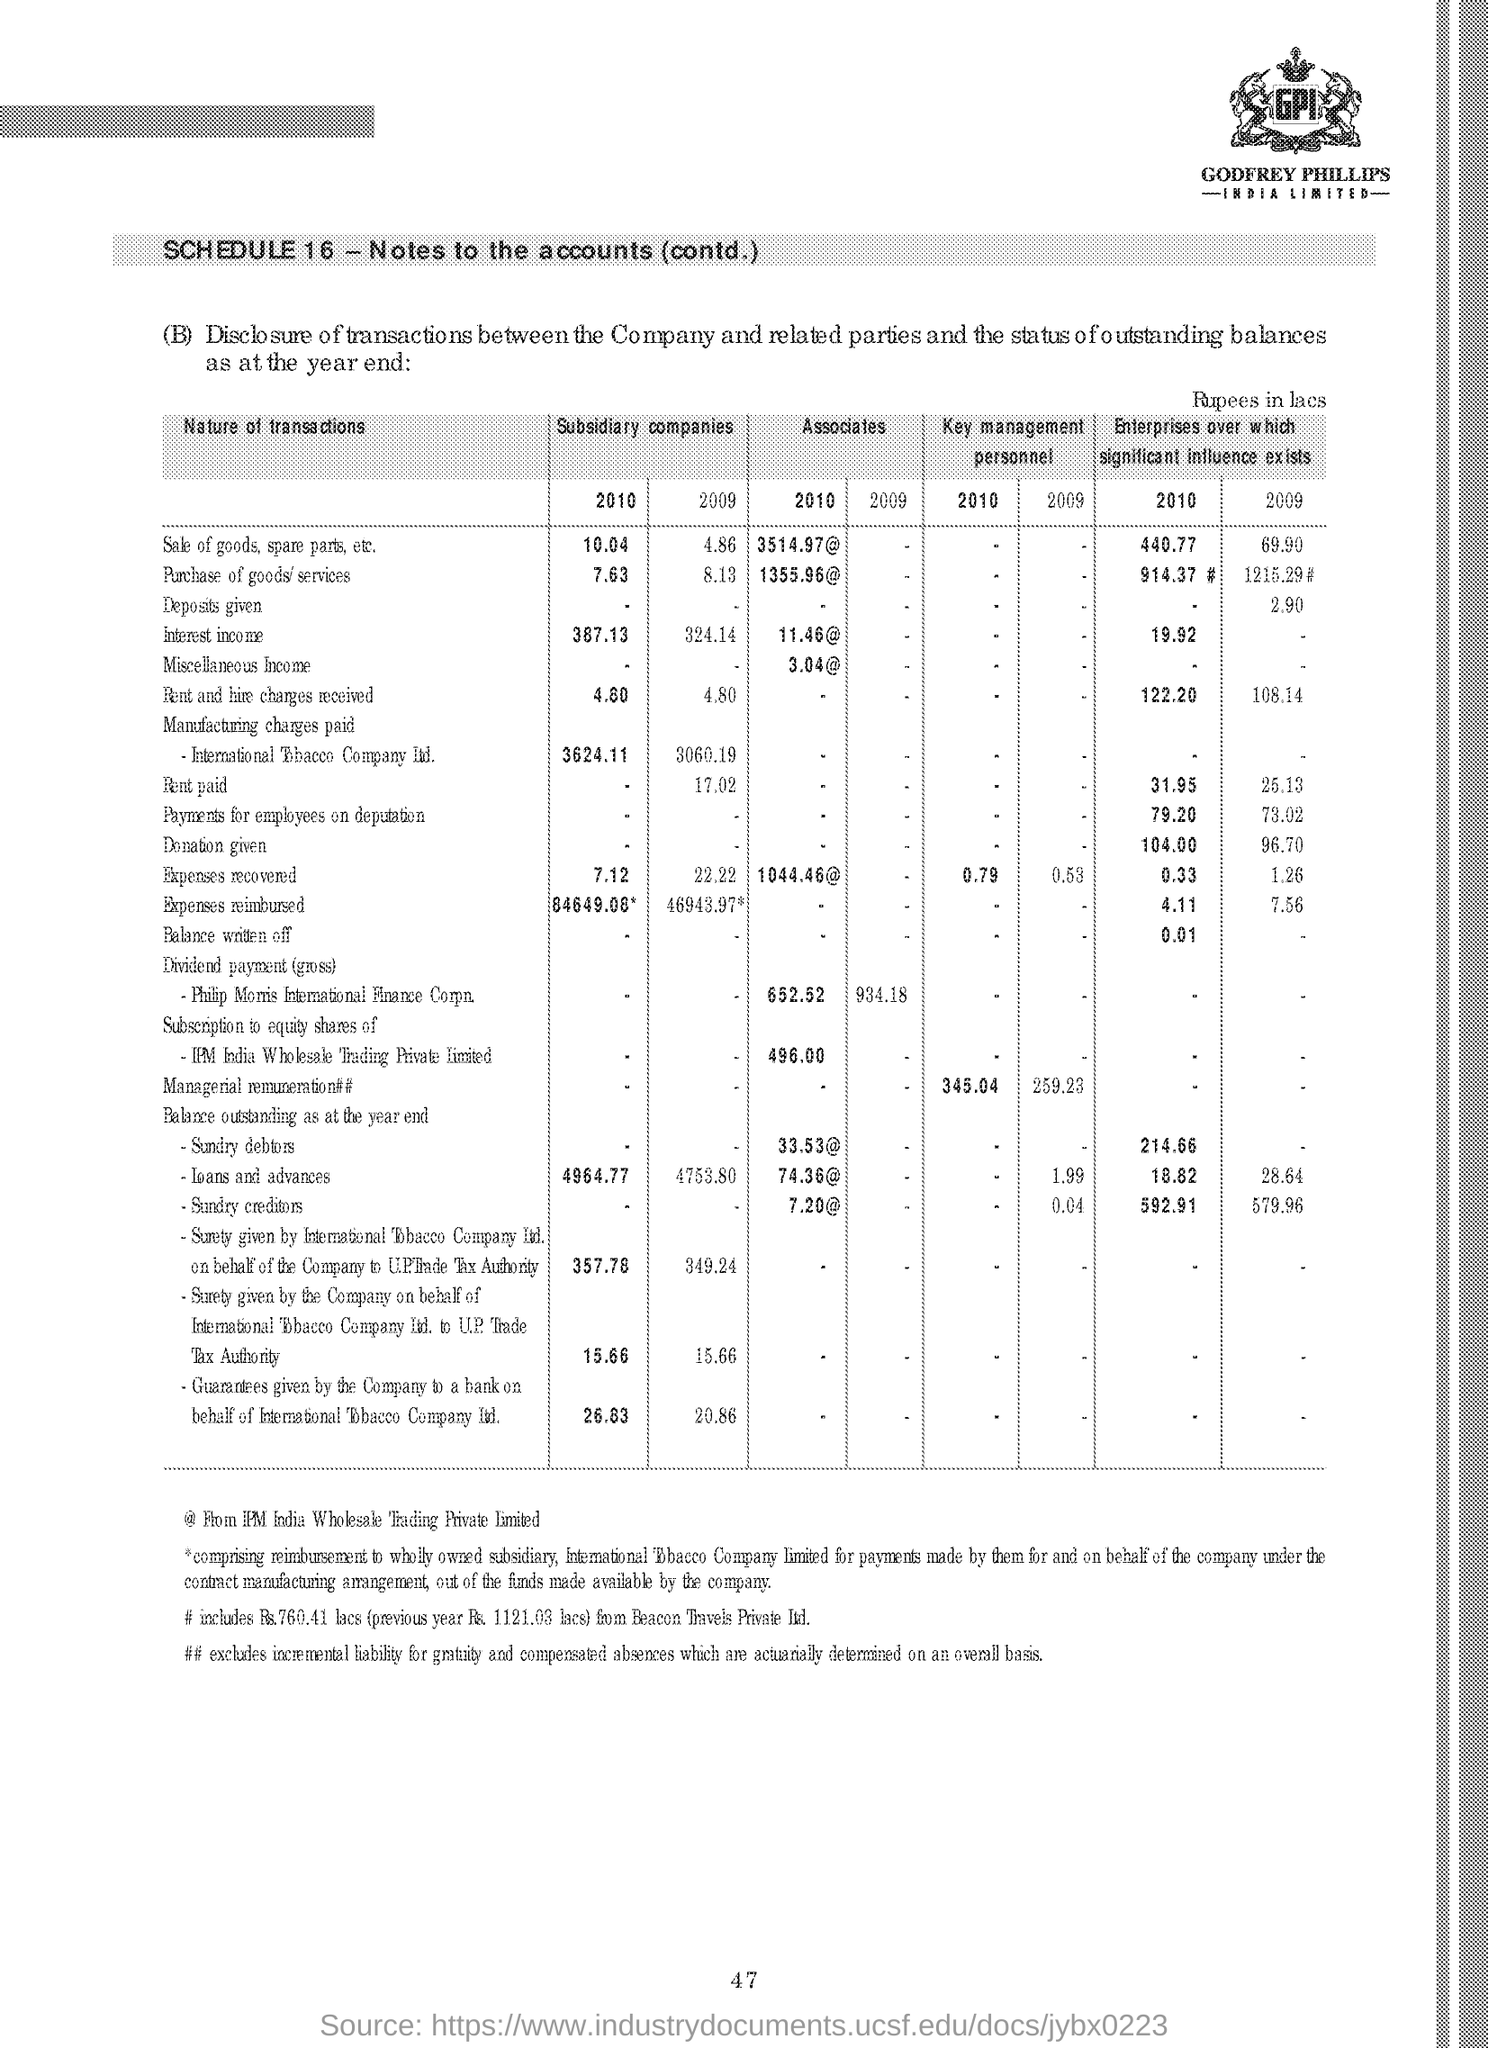Can you provide a comparison of sales from 2009 to 2010 for subsidiary companies? Certainly! In 2009, the sale of goods, spare parts, and other items by subsidiary companies was 4.36 crore. This amount increased to 10.04 crore in 2010, indicating a significant growth. 